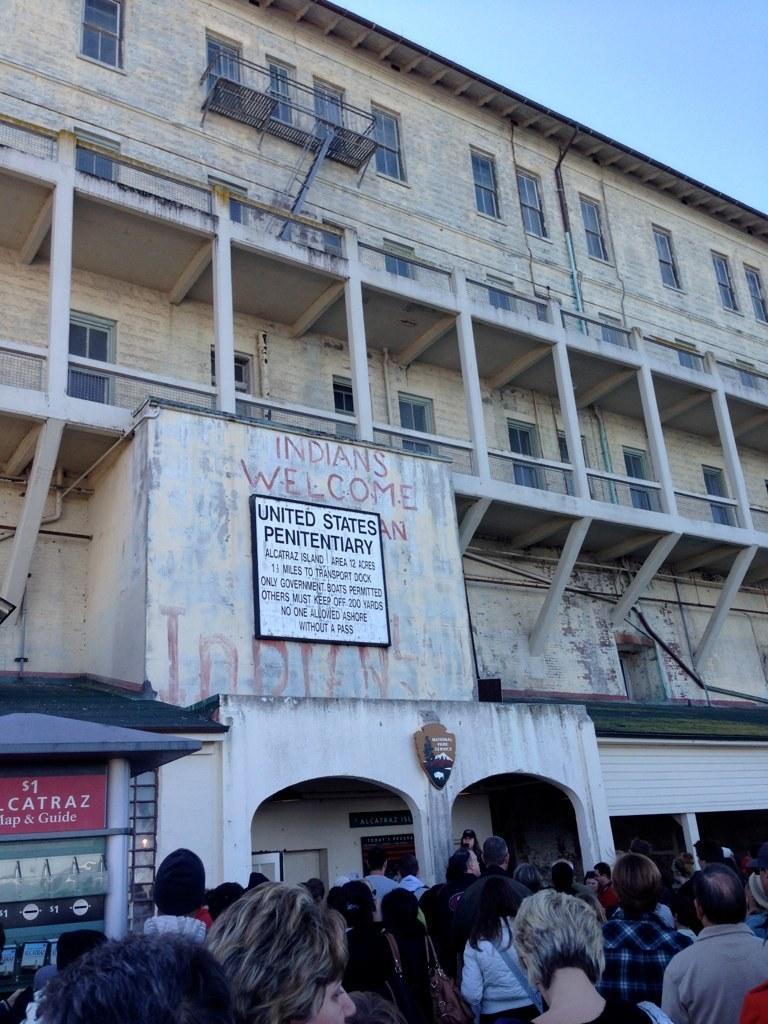Describe this image in one or two sentences. In this image I can see few persons standing in the ground and a building which is cream in color. I can see few windows of the building, a white colored board attached to the building, a small shed to which I can see a red colored board and in the background I can see the sky. 